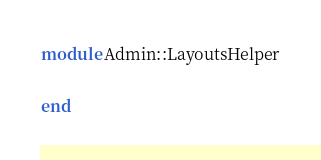<code> <loc_0><loc_0><loc_500><loc_500><_Ruby_>module Admin::LayoutsHelper

end
</code> 